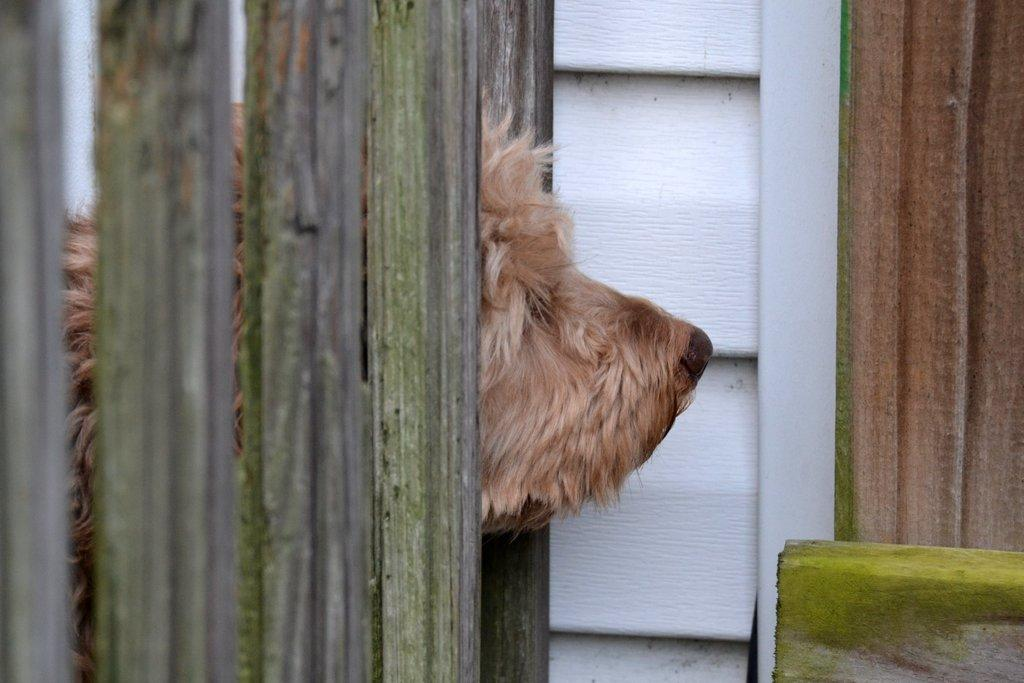What type of animal can be seen in the image? There is a dog in the image. Where is the dog located in relation to other objects? The dog is behind a wooden fence. What can be seen in the background of the image? There is a wall in the background of the image. Can you describe the object in the bottom right corner of the image? Unfortunately, the facts provided do not give any information about the object in the bottom right corner of the image. What type of breakfast is the dog eating in the image? There is no breakfast present in the image, as it features a dog behind a wooden fence with a wall in the background. 